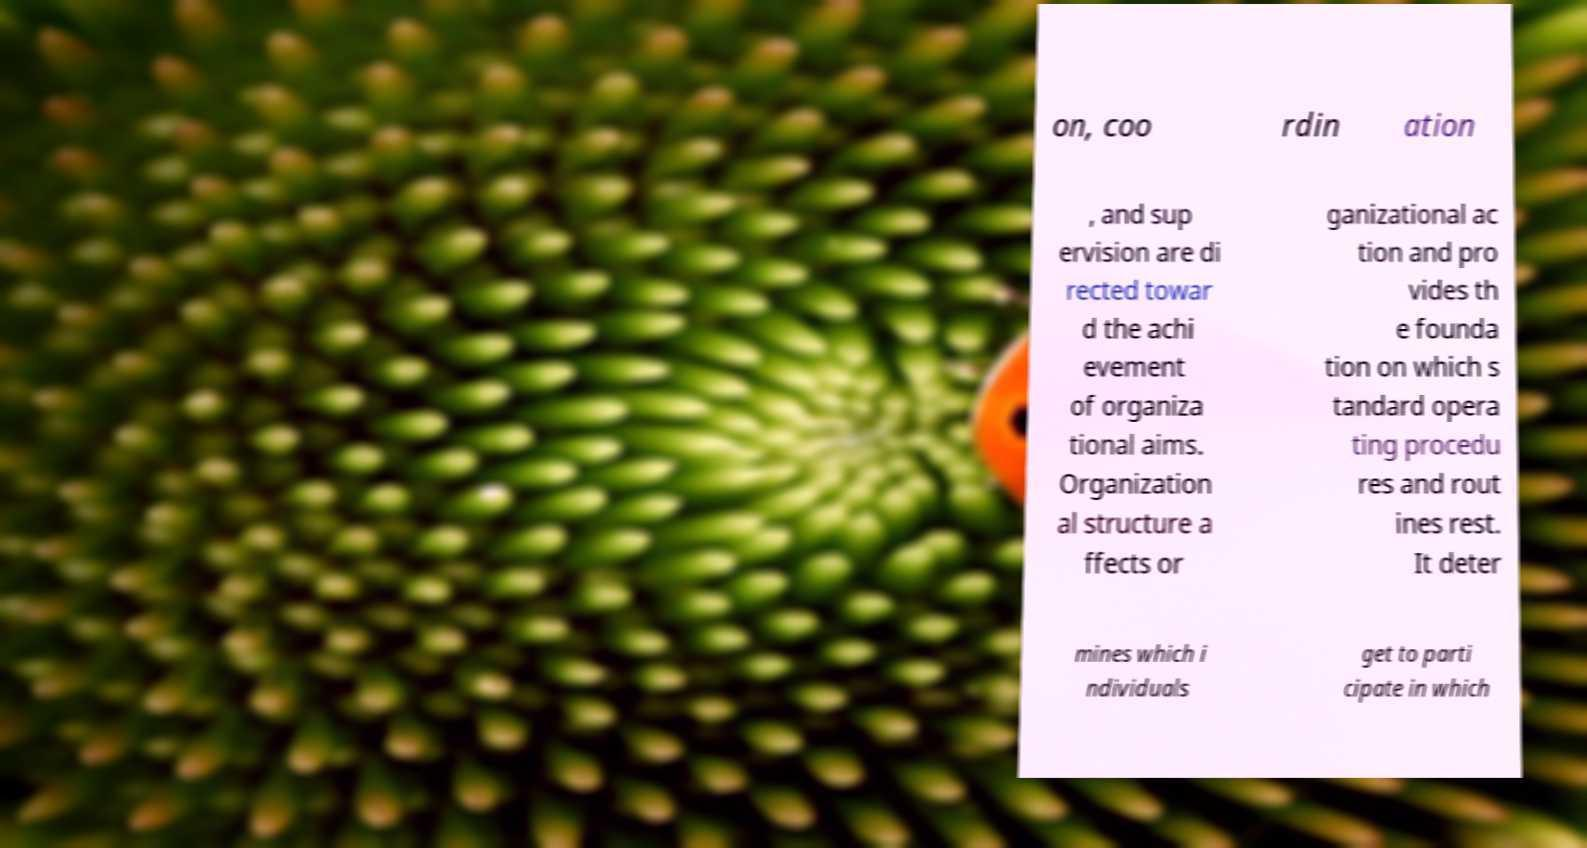What messages or text are displayed in this image? I need them in a readable, typed format. on, coo rdin ation , and sup ervision are di rected towar d the achi evement of organiza tional aims. Organization al structure a ffects or ganizational ac tion and pro vides th e founda tion on which s tandard opera ting procedu res and rout ines rest. It deter mines which i ndividuals get to parti cipate in which 